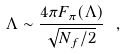Convert formula to latex. <formula><loc_0><loc_0><loc_500><loc_500>\Lambda \sim \frac { 4 \pi F _ { \pi } ( \Lambda ) } { \sqrt { N _ { f } / 2 } } \ ,</formula> 